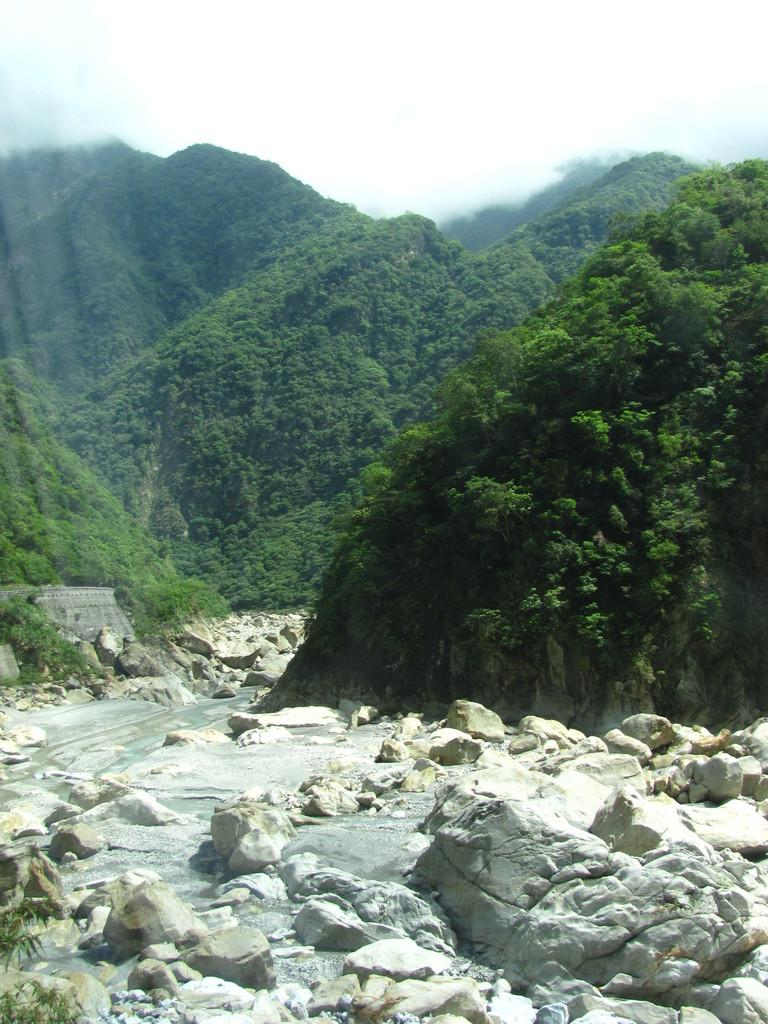What type of natural elements can be seen in the image? There are stones in the image. What type of landscape is visible in the background of the image? There are mountains and trees in the background of the image. What is the condition of the sky in the image? The sky is clear and visible in the background of the image. How many matches are present in the image? There are no matches present in the image. What time of day is depicted in the image? The provided facts do not give information about the time of day, so it cannot be determined from the image. 